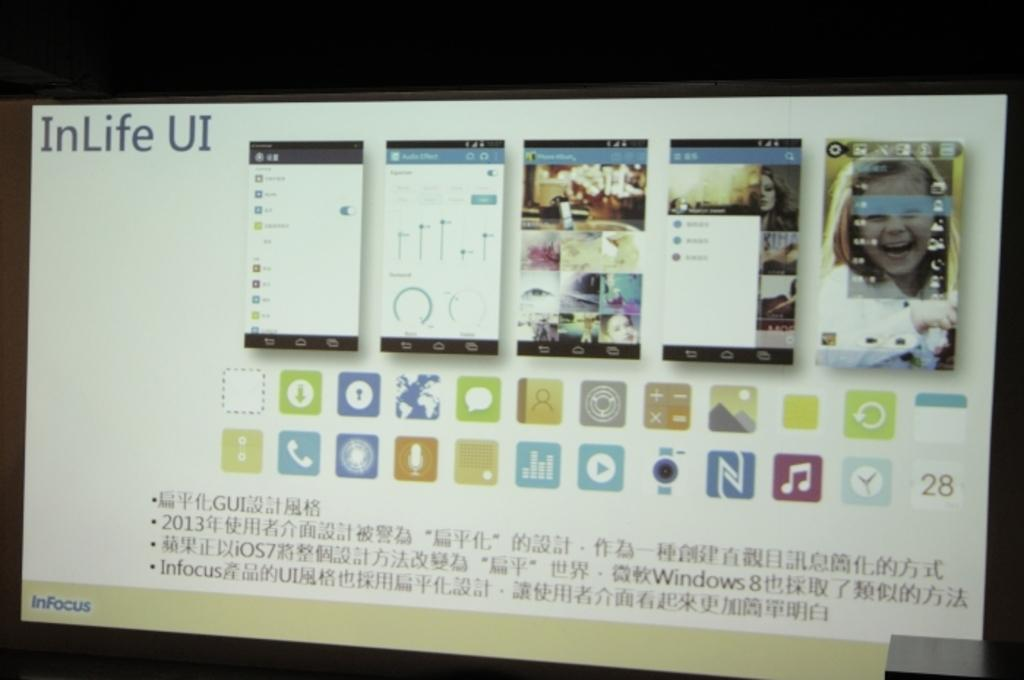What is the main object in the image? There is a screen in the image. What type of content is displayed on the screen? There are mobile screenshots visible on the screen. What other elements can be seen on the screen? There are icons, text, and images visible on the screen. Can you see any mines in the image? There are no mines present in the image. What type of cactus is visible in the image? There is no cactus present in the image. 